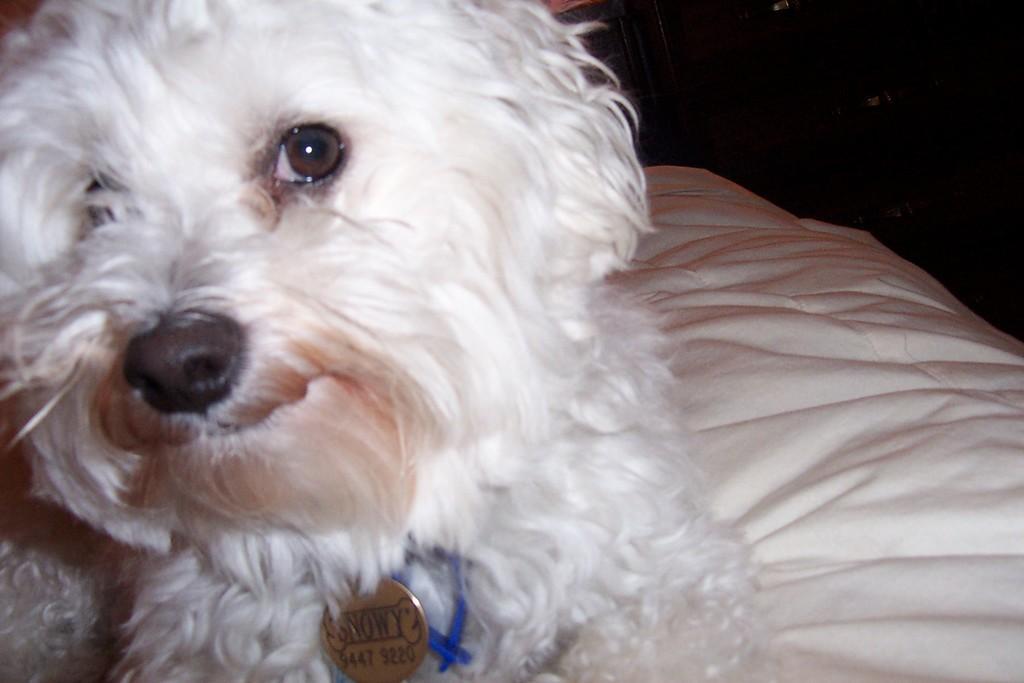Could you give a brief overview of what you see in this image? On the left side of this image I can see a white color dog is sitting on the bed. The background is in black color. I can see a locket and a blue color thread to the dog's neck. 